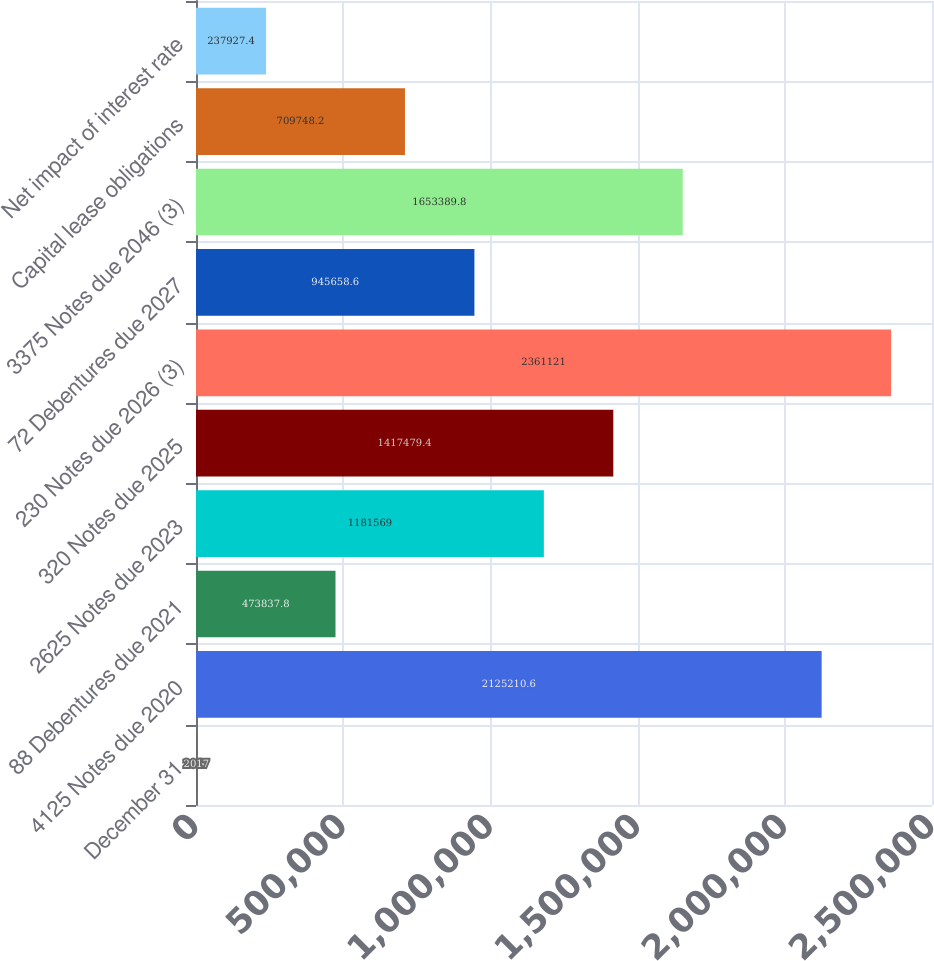Convert chart. <chart><loc_0><loc_0><loc_500><loc_500><bar_chart><fcel>December 31<fcel>4125 Notes due 2020<fcel>88 Debentures due 2021<fcel>2625 Notes due 2023<fcel>320 Notes due 2025<fcel>230 Notes due 2026 (3)<fcel>72 Debentures due 2027<fcel>3375 Notes due 2046 (3)<fcel>Capital lease obligations<fcel>Net impact of interest rate<nl><fcel>2017<fcel>2.12521e+06<fcel>473838<fcel>1.18157e+06<fcel>1.41748e+06<fcel>2.36112e+06<fcel>945659<fcel>1.65339e+06<fcel>709748<fcel>237927<nl></chart> 